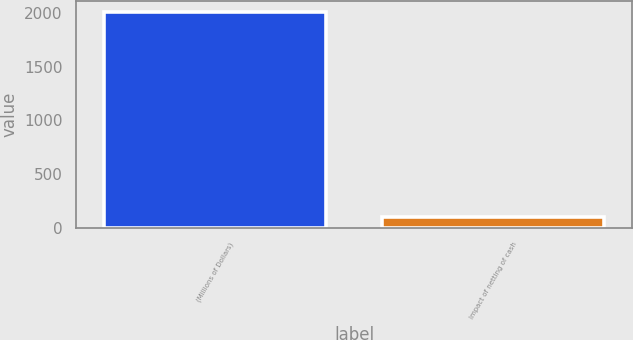Convert chart. <chart><loc_0><loc_0><loc_500><loc_500><bar_chart><fcel>(Millions of Dollars)<fcel>Impact of netting of cash<nl><fcel>2010<fcel>104<nl></chart> 